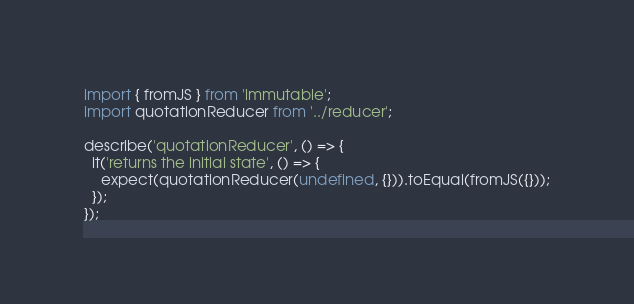Convert code to text. <code><loc_0><loc_0><loc_500><loc_500><_JavaScript_>
import { fromJS } from 'immutable';
import quotationReducer from '../reducer';

describe('quotationReducer', () => {
  it('returns the initial state', () => {
    expect(quotationReducer(undefined, {})).toEqual(fromJS({}));
  });
});
</code> 